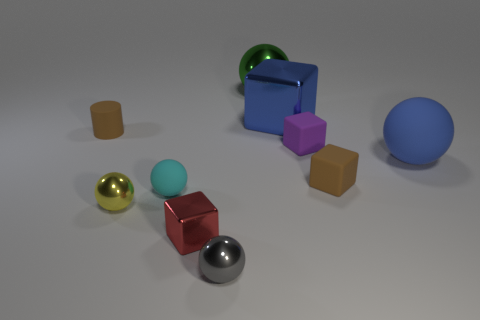Subtract all tiny red metal blocks. How many blocks are left? 3 Subtract all purple blocks. How many blocks are left? 3 Subtract all gray spheres. Subtract all green blocks. How many spheres are left? 4 Subtract all cubes. How many objects are left? 6 Add 2 blue rubber spheres. How many blue rubber spheres exist? 3 Subtract 0 yellow cubes. How many objects are left? 10 Subtract all large yellow metal spheres. Subtract all brown things. How many objects are left? 8 Add 9 yellow balls. How many yellow balls are left? 10 